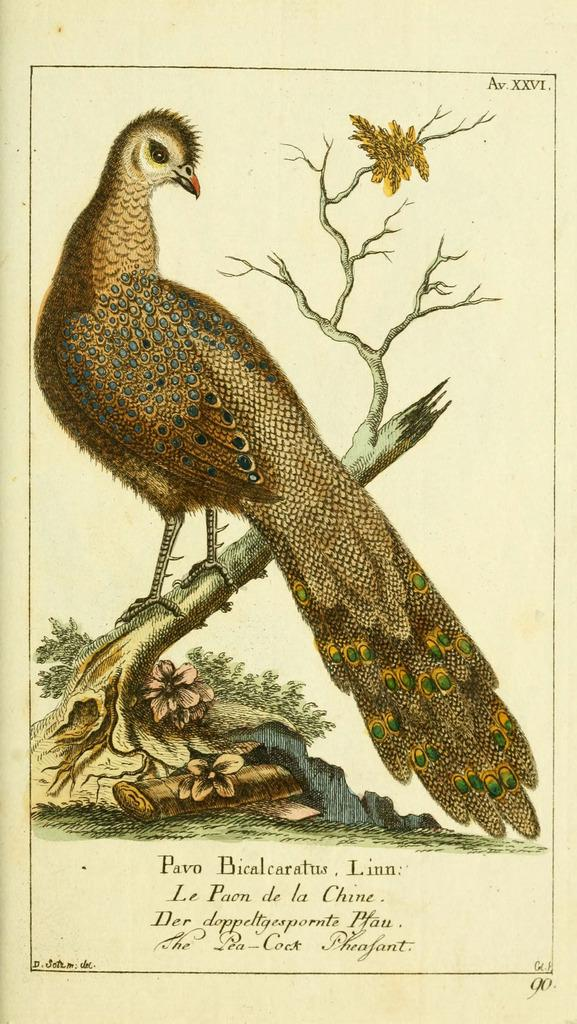What is featured on the poster in the image? The poster contains an image of a peacock. What other elements are included on the poster besides the peacock? The poster includes branches, flowers, and leaves. Is there any text on the poster? Yes, there is text written on the poster. How much wealth does the lettuce on the poster represent? There is no lettuce present on the poster; it features a peacock, branches, flowers, leaves, and text. 